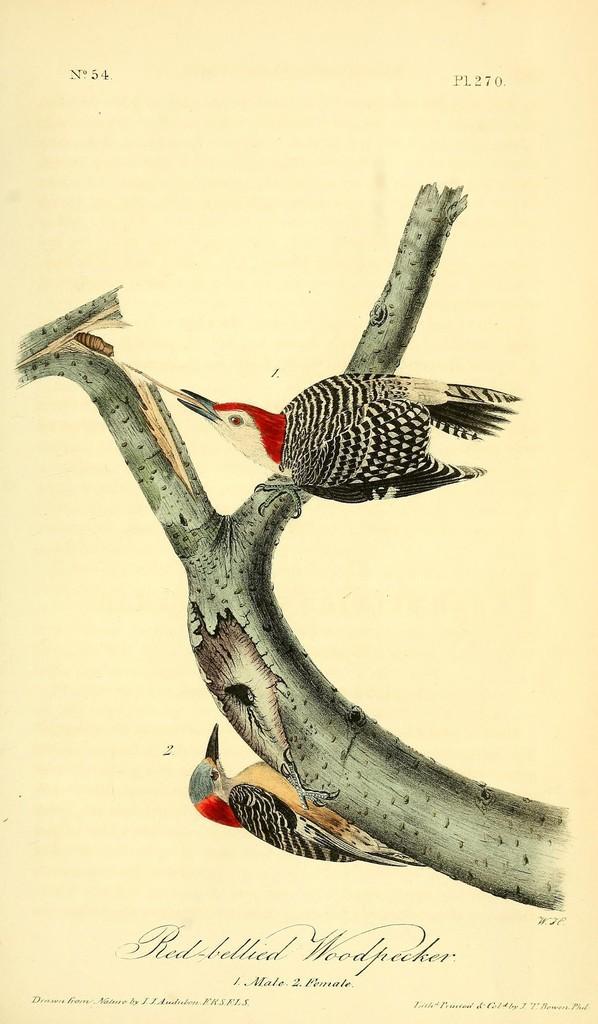Could you give a brief overview of what you see in this image? In this image there is a picture of a stem and two birds. On stem there are two birds standing in opposite direction. Left side of image there is an insect in between the woods. Bottom of image there is some text. 